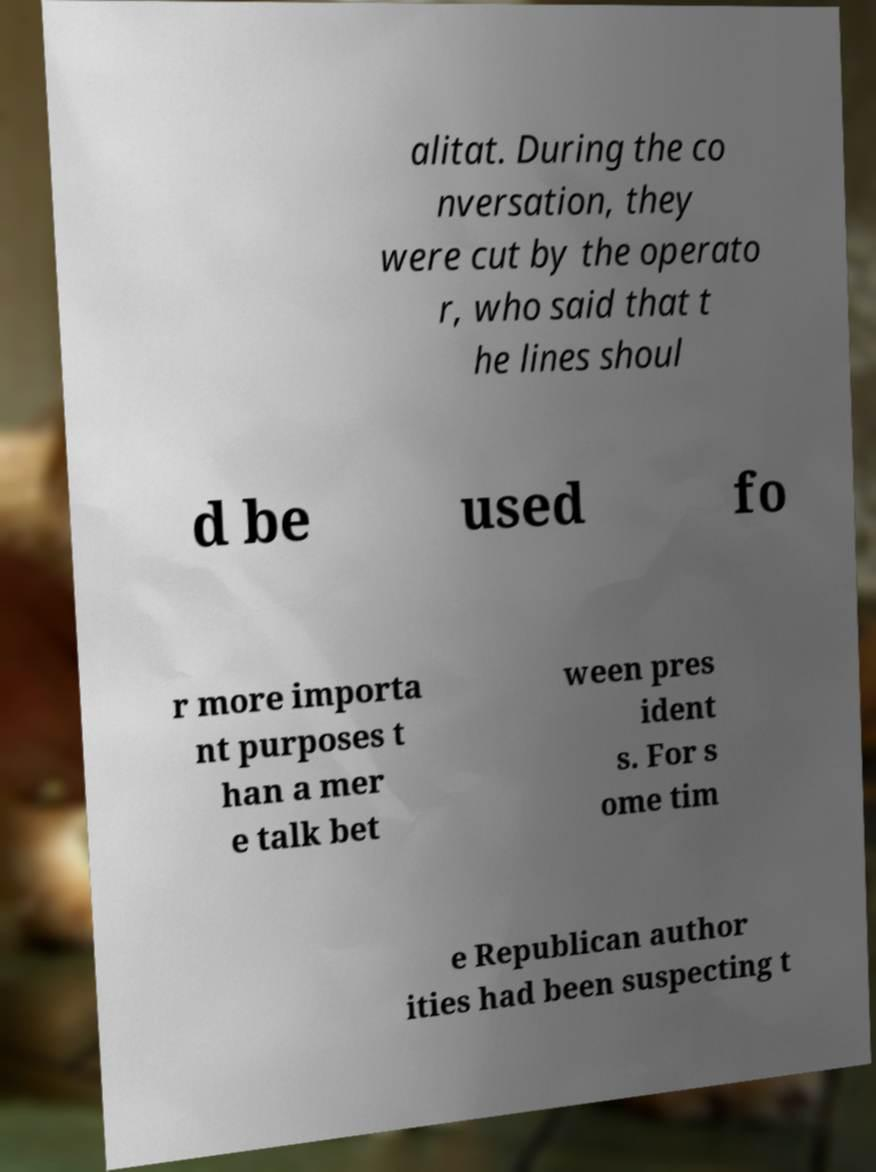There's text embedded in this image that I need extracted. Can you transcribe it verbatim? alitat. During the co nversation, they were cut by the operato r, who said that t he lines shoul d be used fo r more importa nt purposes t han a mer e talk bet ween pres ident s. For s ome tim e Republican author ities had been suspecting t 